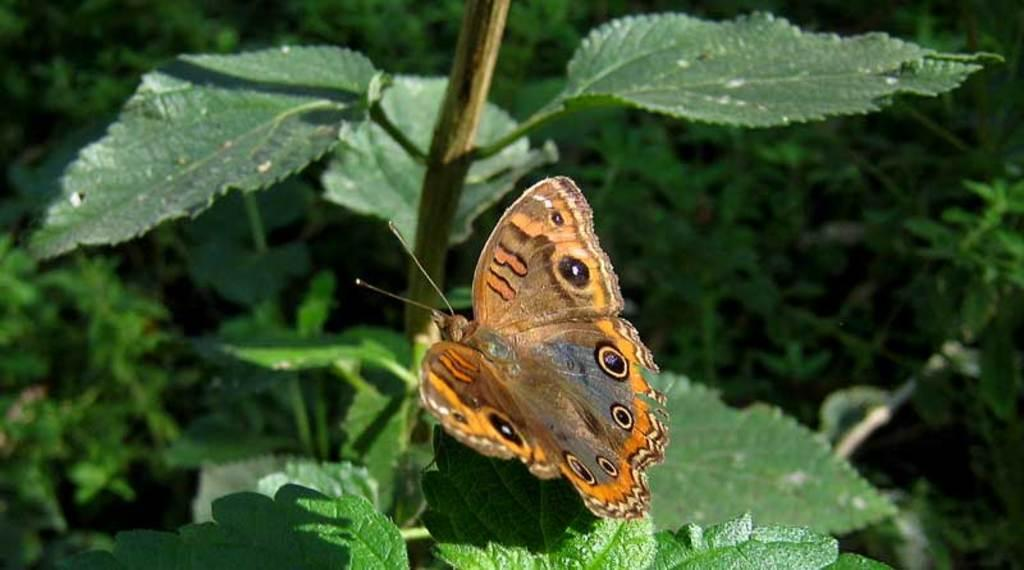What is on the plant in the image? There is a butterfly on a plant in the image. What color is the plant that the butterfly is on? The plant is green in color. What can be seen in the background of the image? There are many plants visible in the background of the image. What type of drum is being played on the sidewalk in the image? There is no drum or sidewalk present in the image; it features a butterfly on a green plant. 